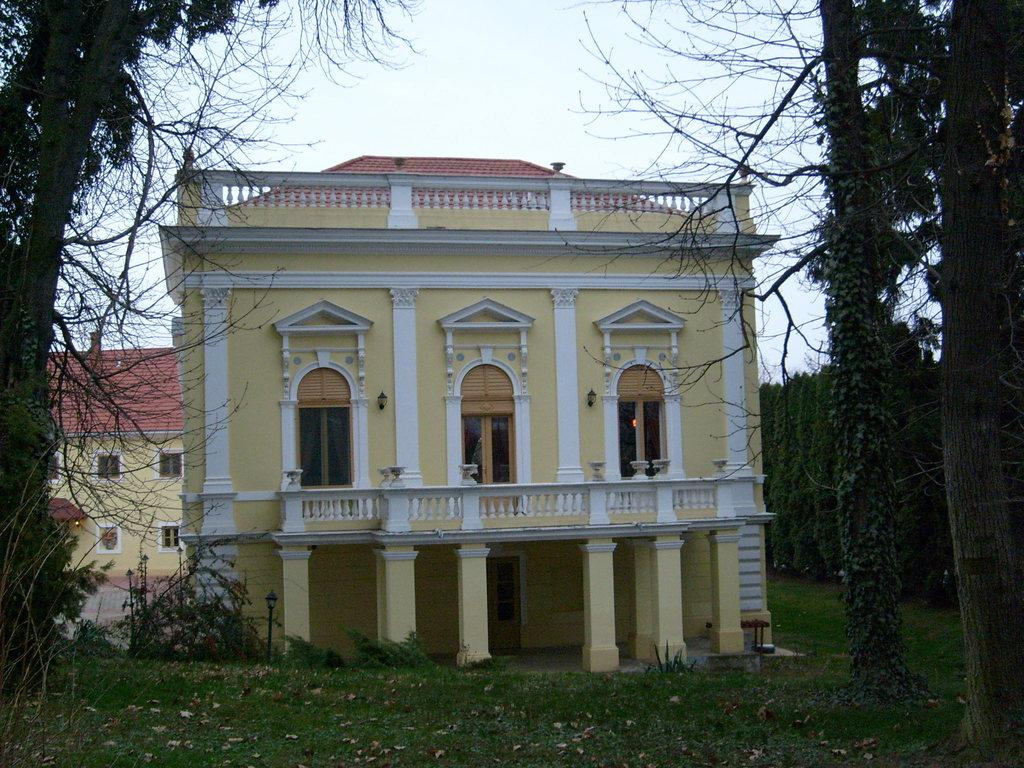What type of structures can be seen in the image? There are buildings in the image. What type of vegetation is present in the image? There are trees in the image. What type of ground cover can be seen in the image? There is grass in the image. What type of bell can be seen hanging from the tree in the image? There is no bell present in the image; it only features buildings, trees, and grass. What advice does the coach give to the dad in the image? There is no dad or coach present in the image; it only features buildings, trees, and grass. 